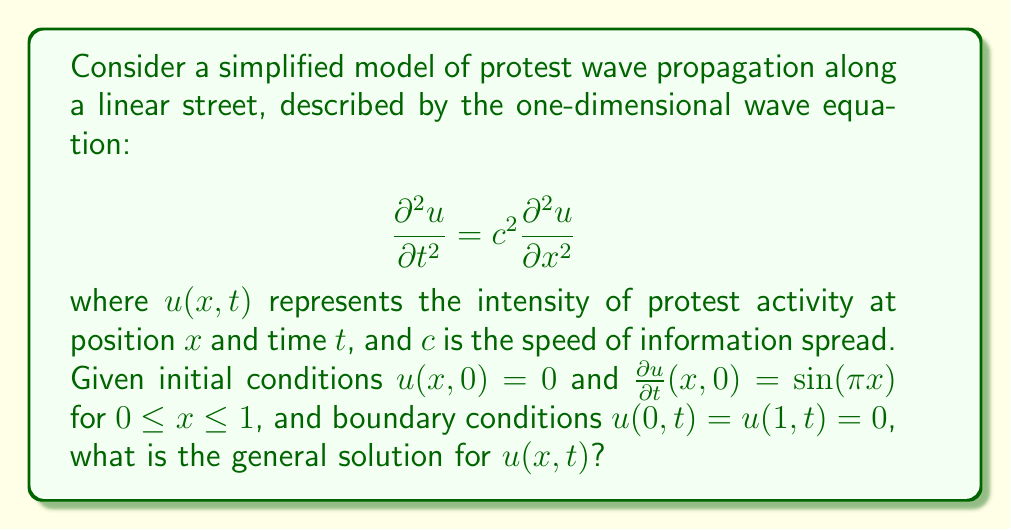Give your solution to this math problem. To solve this problem, we'll follow these steps:

1) The general solution to the wave equation with these boundary conditions is of the form:

   $$u(x,t) = \sum_{n=1}^{\infty} (A_n \cos(n\pi ct) + B_n \sin(n\pi ct)) \sin(n\pi x)$$

2) We're given that $u(x,0) = 0$, which means all $A_n = 0$.

3) Now we need to find $B_n$ using the initial velocity condition:

   $$\frac{\partial u}{\partial t}(x,0) = \sum_{n=1}^{\infty} n\pi c B_n \sin(n\pi x) = \sin(\pi x)$$

4) Comparing coefficients, we see that $B_1 = \frac{1}{\pi c}$ and all other $B_n = 0$.

5) Therefore, the general solution is:

   $$u(x,t) = \frac{1}{\pi c} \sin(\pi ct) \sin(\pi x)$$

This solution represents a standing wave, where the spatial pattern of protest intensity oscillates in place over time, with nodes (points of zero activity) at the ends of the street.
Answer: $$u(x,t) = \frac{1}{\pi c} \sin(\pi ct) \sin(\pi x)$$ 